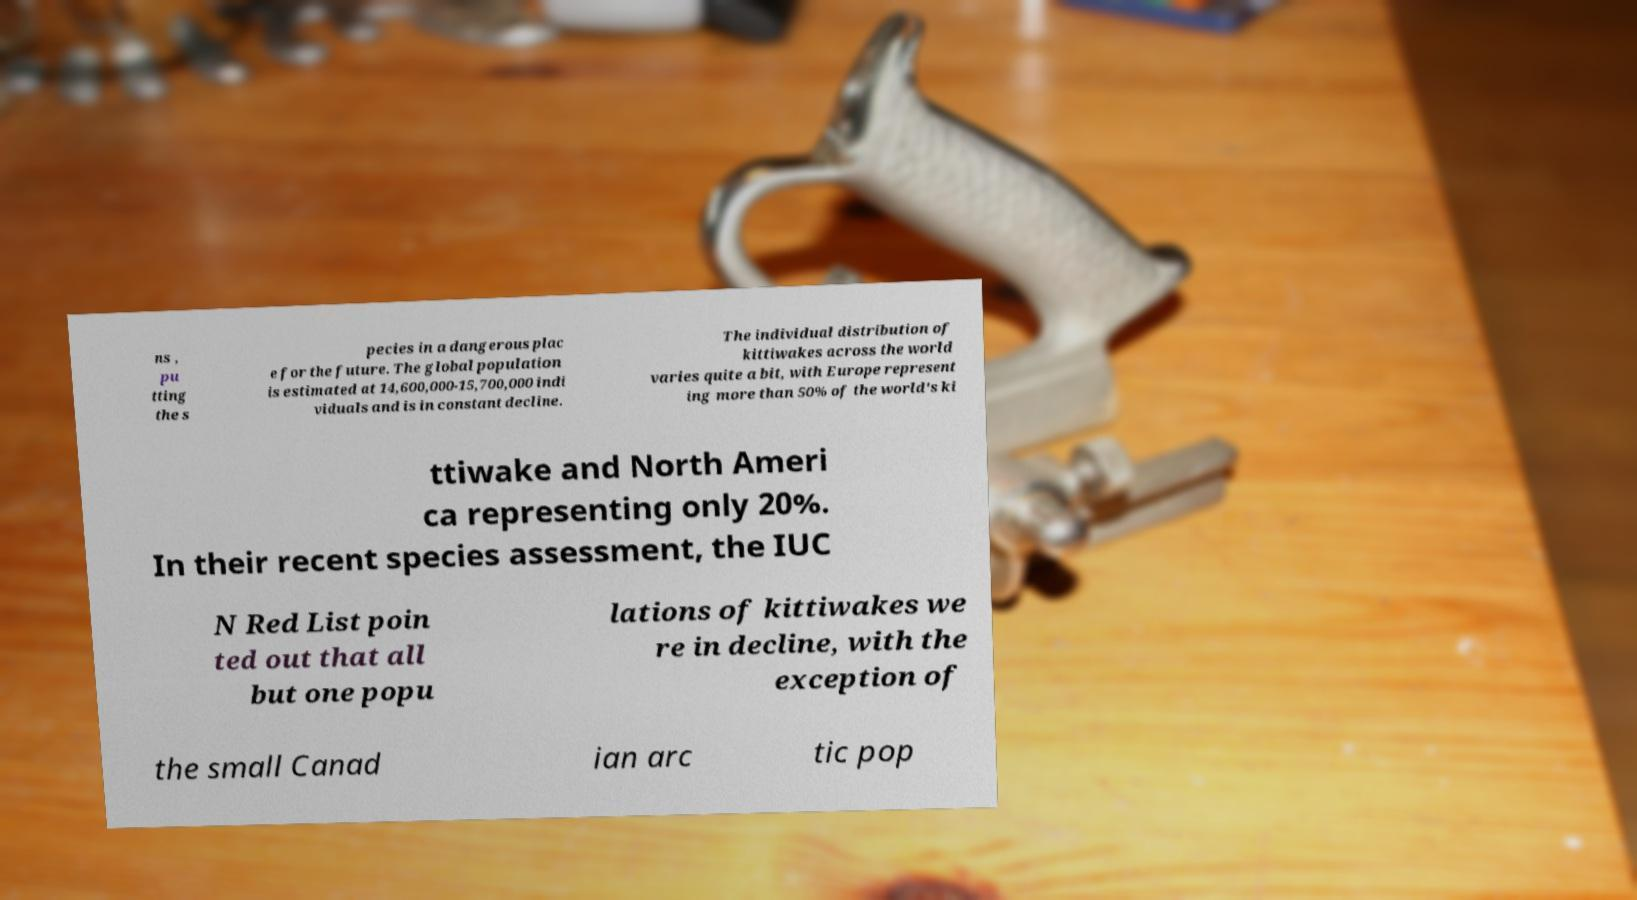There's text embedded in this image that I need extracted. Can you transcribe it verbatim? ns , pu tting the s pecies in a dangerous plac e for the future. The global population is estimated at 14,600,000-15,700,000 indi viduals and is in constant decline. The individual distribution of kittiwakes across the world varies quite a bit, with Europe represent ing more than 50% of the world's ki ttiwake and North Ameri ca representing only 20%. In their recent species assessment, the IUC N Red List poin ted out that all but one popu lations of kittiwakes we re in decline, with the exception of the small Canad ian arc tic pop 